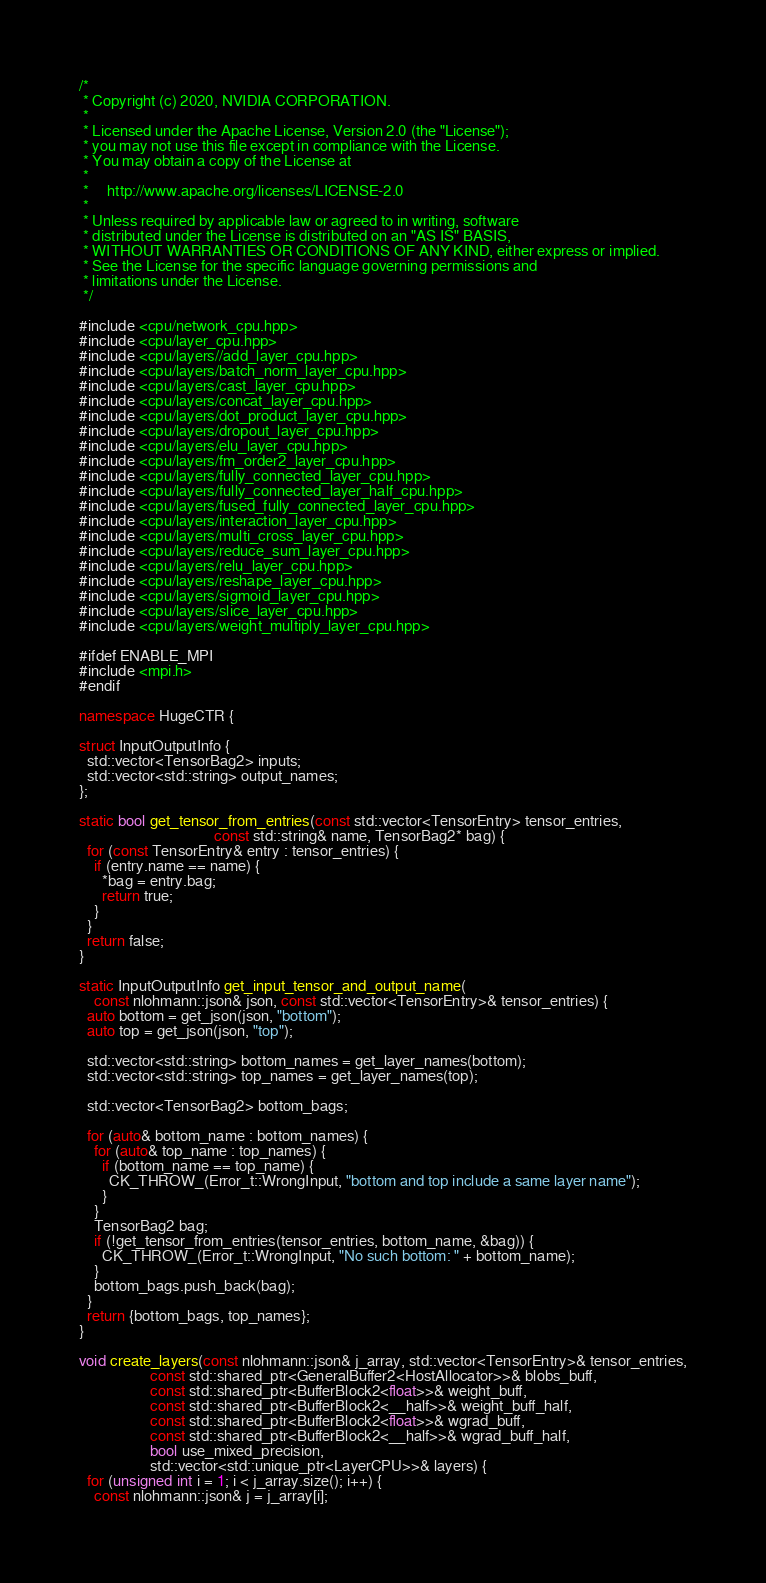<code> <loc_0><loc_0><loc_500><loc_500><_C++_>/*
 * Copyright (c) 2020, NVIDIA CORPORATION.
 *
 * Licensed under the Apache License, Version 2.0 (the "License");
 * you may not use this file except in compliance with the License.
 * You may obtain a copy of the License at
 *
 *     http://www.apache.org/licenses/LICENSE-2.0
 *
 * Unless required by applicable law or agreed to in writing, software
 * distributed under the License is distributed on an "AS IS" BASIS,
 * WITHOUT WARRANTIES OR CONDITIONS OF ANY KIND, either express or implied.
 * See the License for the specific language governing permissions and
 * limitations under the License.
 */

#include <cpu/network_cpu.hpp>
#include <cpu/layer_cpu.hpp>
#include <cpu/layers//add_layer_cpu.hpp>
#include <cpu/layers/batch_norm_layer_cpu.hpp>
#include <cpu/layers/cast_layer_cpu.hpp>
#include <cpu/layers/concat_layer_cpu.hpp>
#include <cpu/layers/dot_product_layer_cpu.hpp>
#include <cpu/layers/dropout_layer_cpu.hpp>
#include <cpu/layers/elu_layer_cpu.hpp>
#include <cpu/layers/fm_order2_layer_cpu.hpp>
#include <cpu/layers/fully_connected_layer_cpu.hpp>
#include <cpu/layers/fully_connected_layer_half_cpu.hpp>
#include <cpu/layers/fused_fully_connected_layer_cpu.hpp>
#include <cpu/layers/interaction_layer_cpu.hpp>
#include <cpu/layers/multi_cross_layer_cpu.hpp>
#include <cpu/layers/reduce_sum_layer_cpu.hpp>
#include <cpu/layers/relu_layer_cpu.hpp>
#include <cpu/layers/reshape_layer_cpu.hpp>
#include <cpu/layers/sigmoid_layer_cpu.hpp>
#include <cpu/layers/slice_layer_cpu.hpp>
#include <cpu/layers/weight_multiply_layer_cpu.hpp>

#ifdef ENABLE_MPI
#include <mpi.h>
#endif

namespace HugeCTR {

struct InputOutputInfo {
  std::vector<TensorBag2> inputs;
  std::vector<std::string> output_names;
};

static bool get_tensor_from_entries(const std::vector<TensorEntry> tensor_entries,
                                    const std::string& name, TensorBag2* bag) {
  for (const TensorEntry& entry : tensor_entries) {
    if (entry.name == name) {
      *bag = entry.bag;
      return true;
    }
  }
  return false;
}

static InputOutputInfo get_input_tensor_and_output_name(
    const nlohmann::json& json, const std::vector<TensorEntry>& tensor_entries) {
  auto bottom = get_json(json, "bottom");
  auto top = get_json(json, "top");

  std::vector<std::string> bottom_names = get_layer_names(bottom);
  std::vector<std::string> top_names = get_layer_names(top);

  std::vector<TensorBag2> bottom_bags;

  for (auto& bottom_name : bottom_names) {
    for (auto& top_name : top_names) {
      if (bottom_name == top_name) {
        CK_THROW_(Error_t::WrongInput, "bottom and top include a same layer name");
      }
    }
    TensorBag2 bag;
    if (!get_tensor_from_entries(tensor_entries, bottom_name, &bag)) {
      CK_THROW_(Error_t::WrongInput, "No such bottom: " + bottom_name);
    }
    bottom_bags.push_back(bag);
  }
  return {bottom_bags, top_names};
}

void create_layers(const nlohmann::json& j_array, std::vector<TensorEntry>& tensor_entries,
                   const std::shared_ptr<GeneralBuffer2<HostAllocator>>& blobs_buff,
                   const std::shared_ptr<BufferBlock2<float>>& weight_buff,
                   const std::shared_ptr<BufferBlock2<__half>>& weight_buff_half,
                   const std::shared_ptr<BufferBlock2<float>>& wgrad_buff,
                   const std::shared_ptr<BufferBlock2<__half>>& wgrad_buff_half,
                   bool use_mixed_precision,
                   std::vector<std::unique_ptr<LayerCPU>>& layers) {
  for (unsigned int i = 1; i < j_array.size(); i++) {
    const nlohmann::json& j = j_array[i];</code> 